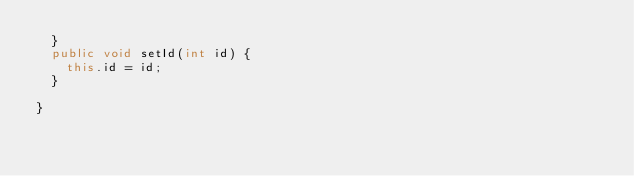<code> <loc_0><loc_0><loc_500><loc_500><_Java_>	}
	public void setId(int id) {
		this.id = id;
	}
	
}
</code> 